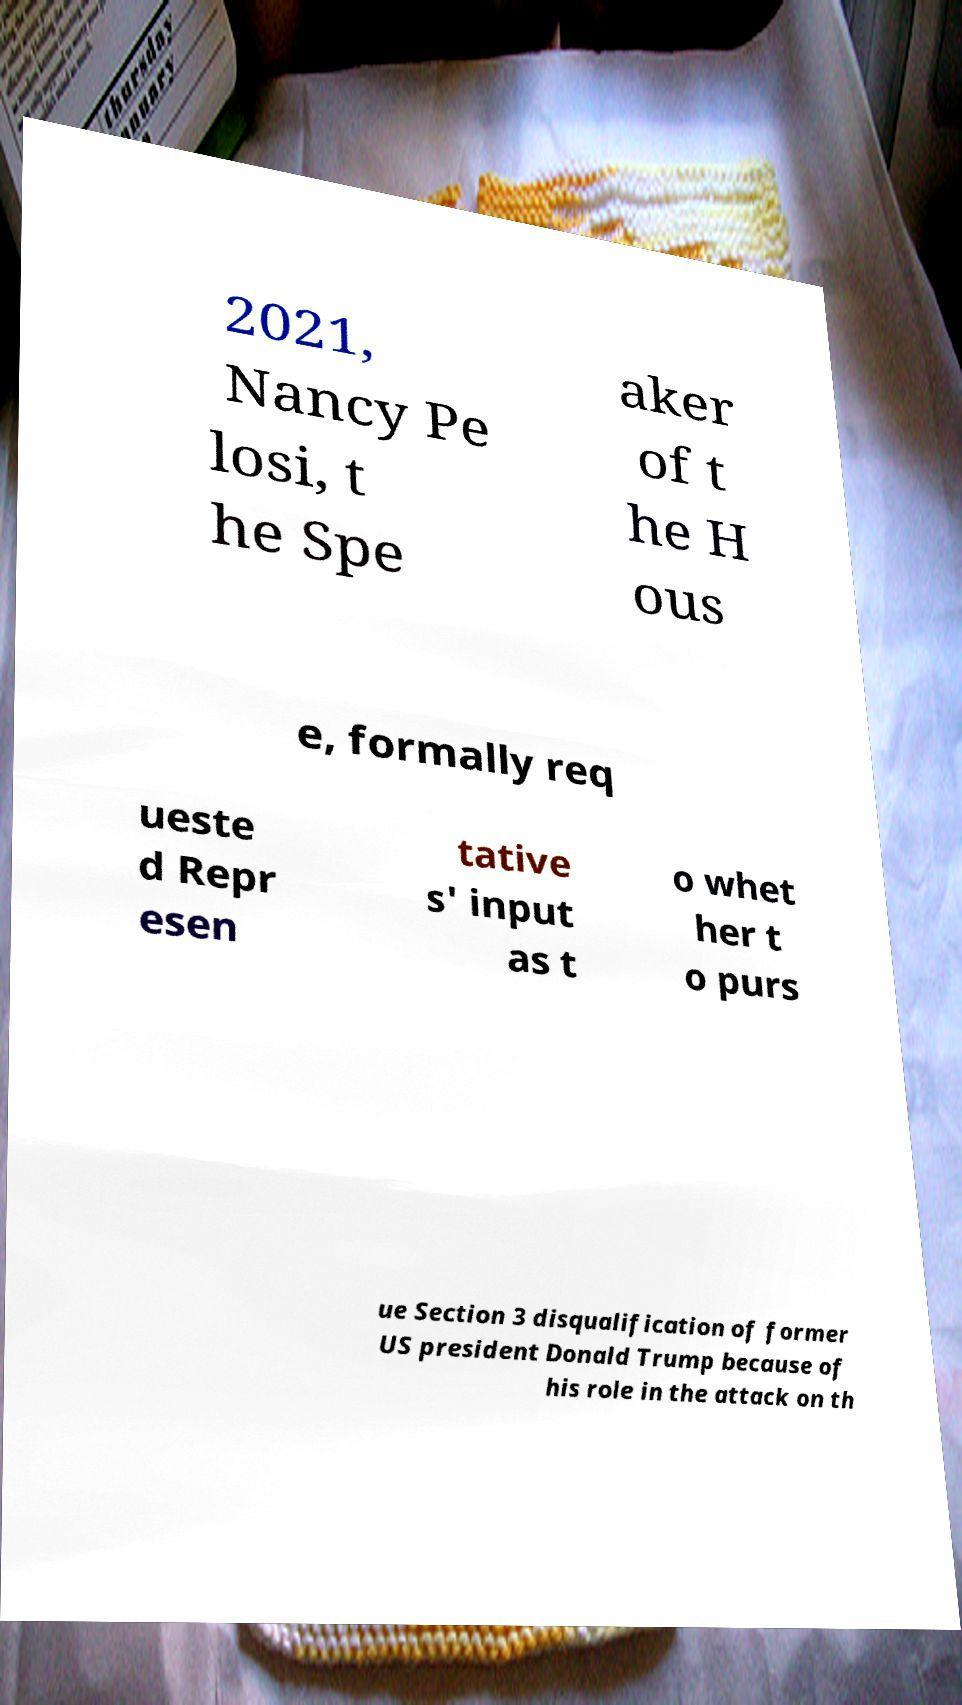Please identify and transcribe the text found in this image. 2021, Nancy Pe losi, t he Spe aker of t he H ous e, formally req ueste d Repr esen tative s' input as t o whet her t o purs ue Section 3 disqualification of former US president Donald Trump because of his role in the attack on th 